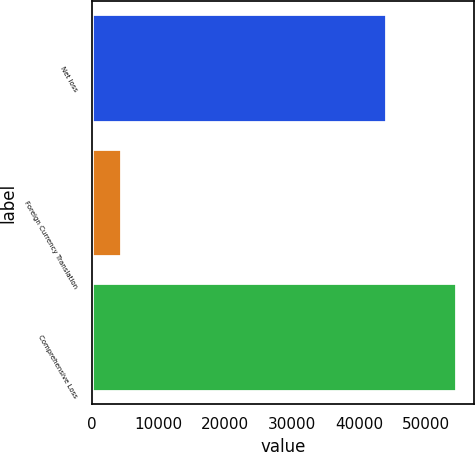<chart> <loc_0><loc_0><loc_500><loc_500><bar_chart><fcel>Net loss<fcel>Foreign Currency Translation<fcel>Comprehensive Loss<nl><fcel>44057<fcel>4388<fcel>54516<nl></chart> 